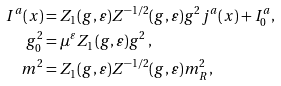<formula> <loc_0><loc_0><loc_500><loc_500>I ^ { a } ( x ) & = Z _ { 1 } ( g , \varepsilon ) Z ^ { - 1 / 2 } ( g , \varepsilon ) g ^ { 2 } j ^ { a } ( x ) + I ^ { a } _ { 0 } , \\ g _ { 0 } ^ { 2 } & = \mu ^ { \varepsilon } Z _ { 1 } ( g , \varepsilon ) g ^ { 2 } \, , \\ m ^ { 2 } & = Z _ { 1 } ( g , \varepsilon ) Z ^ { - 1 / 2 } ( g , \varepsilon ) m ^ { 2 } _ { R } \, ,</formula> 